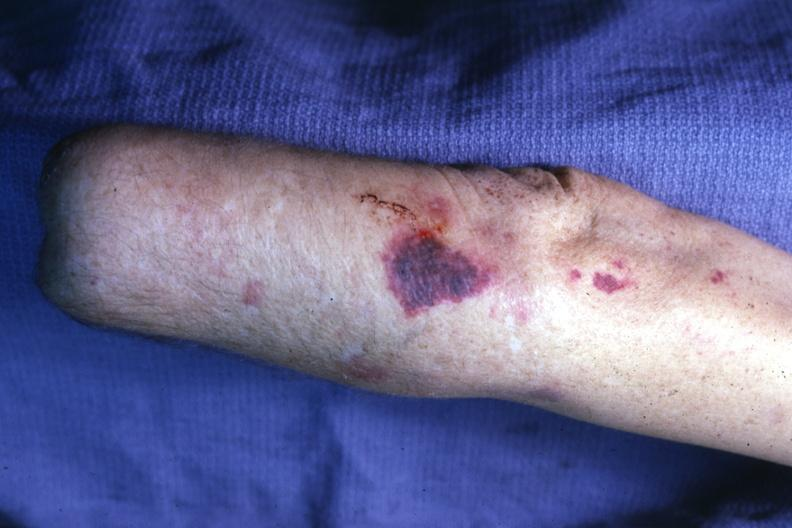does this image show lesion on forearm?
Answer the question using a single word or phrase. Yes 